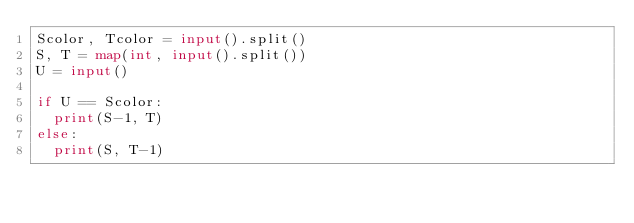<code> <loc_0><loc_0><loc_500><loc_500><_Python_>Scolor, Tcolor = input().split()
S, T = map(int, input().split())
U = input()

if U == Scolor:
  print(S-1, T)
else:
  print(S, T-1)
</code> 